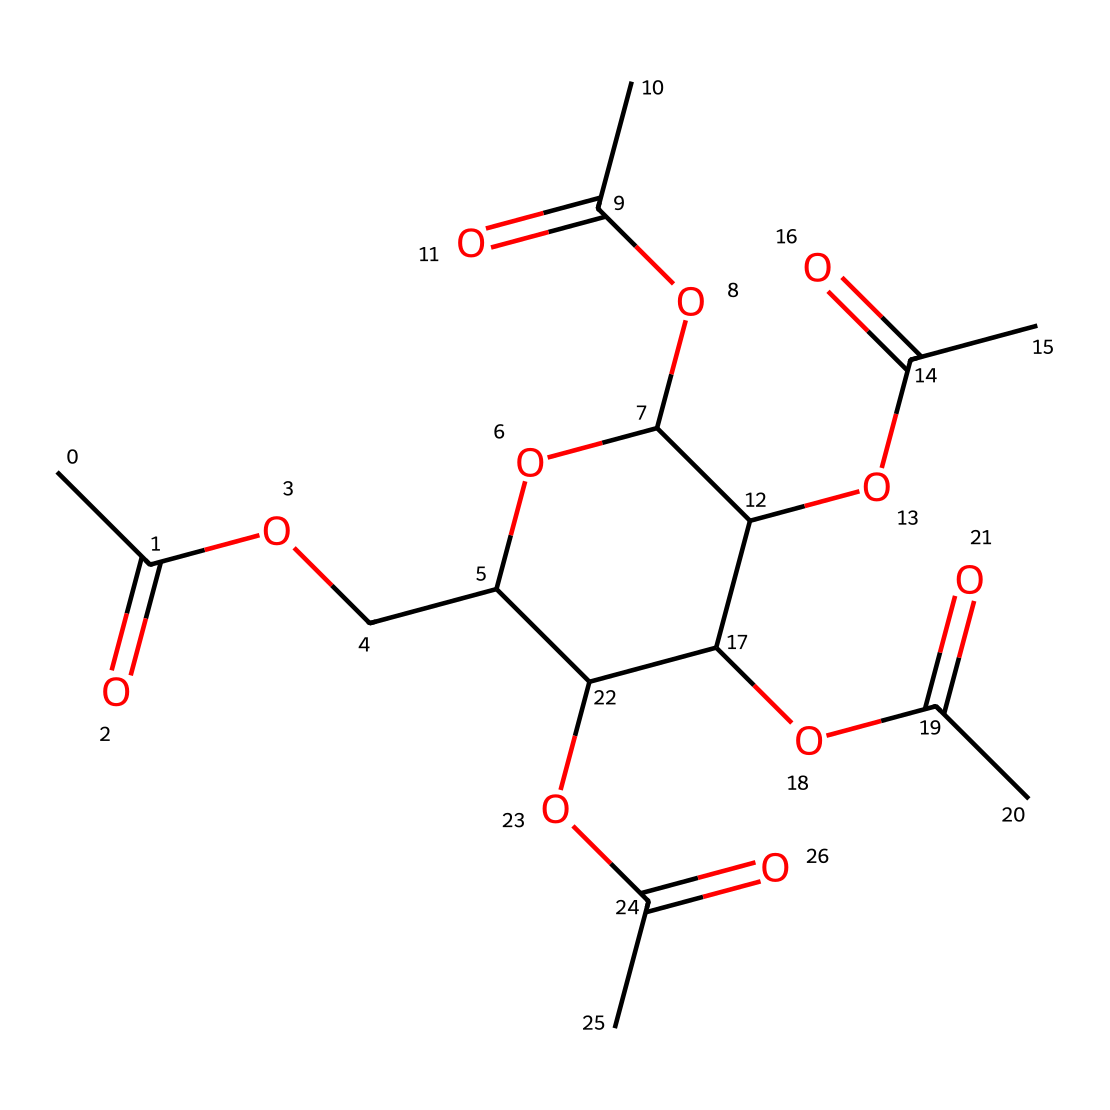What is the main functional group present in this molecule? The main functional group is the ester group, characterized by the carbonyl (C=O) adjacent to an oxygen atom (–O–). In this chemical, there are multiple ester functionalities indicated by the structure.
Answer: ester How many acetyl groups are present in this compound? By examining the structure, each acetyl group is represented by the CC(=O) part, and there are four CC(=O) units connected to the cyclic structure, indicating four acetyl groups in total.
Answer: four What type of compound is cellulose acetate classified as? Cellulose acetate is classified as a synthetic polymer made from cellulose through the reaction with acetic anhydride, which creates the ester functional groups throughout the structure.
Answer: polymer How many oxygen atoms are in the entire structure? Counting the oxygen atoms in the SMILES representation, there are a total of 6 oxygen atoms in the molecule.
Answer: six Does this chemical contain any ring structures? Yes, the structure features a cyclic ring, which is indicated by the "C1" notation in the SMILES, showing that there is a ring formed by the carbon atoms and connected functionalities.
Answer: yes What are the possible applications of cellulose acetate in building materials? Cellulose acetate is commonly used as insulation material due to its thermal properties and biodegradability, making it suitable for environmentally friendly building solutions.
Answer: insulation 